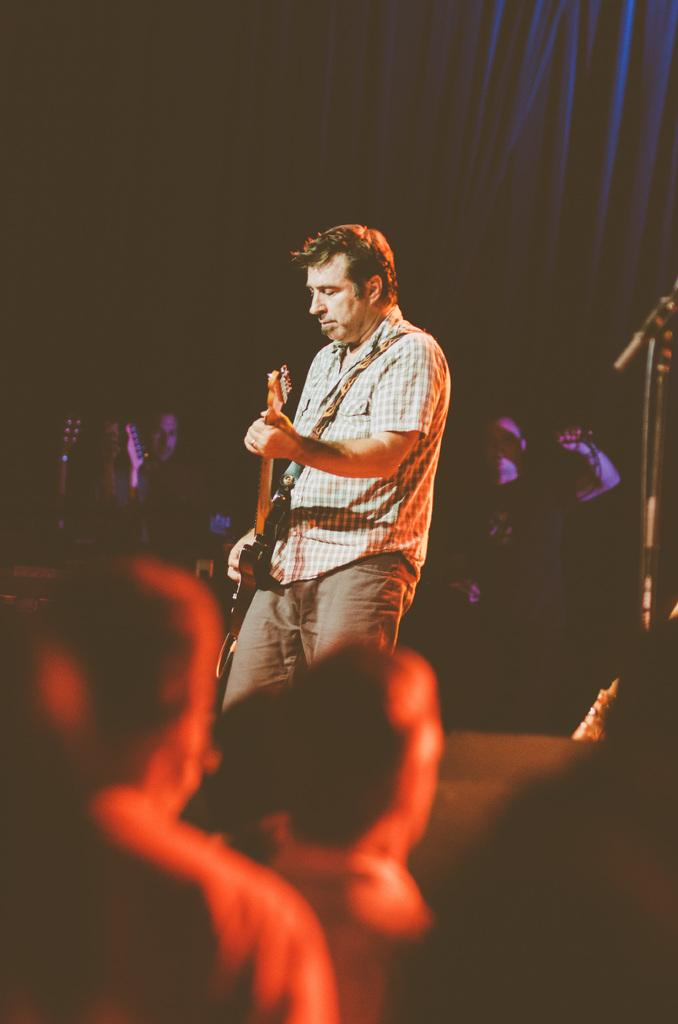What is the main subject of the image? There is a person in the image. What is the person wearing? The person is wearing a check shirt. What is the person holding? The person is holding a guitar. What is the person doing with the guitar? The person is playing the guitar. Are there any other people in the image? Yes, there are other persons in the image. How much wealth does the person in the image possess? The image does not provide any information about the person's wealth, so it cannot be determined. What type of art is displayed on the wall behind the person? There is no art displayed on the wall behind the person in the image. 